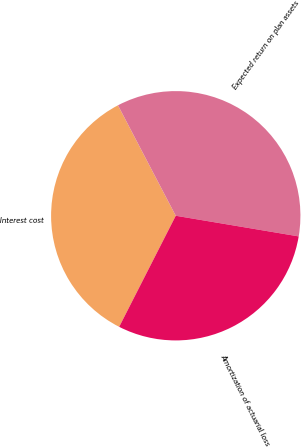<chart> <loc_0><loc_0><loc_500><loc_500><pie_chart><fcel>Interest cost<fcel>Expected return on plan assets<fcel>Amortization of actuarial loss<nl><fcel>34.83%<fcel>35.32%<fcel>29.85%<nl></chart> 